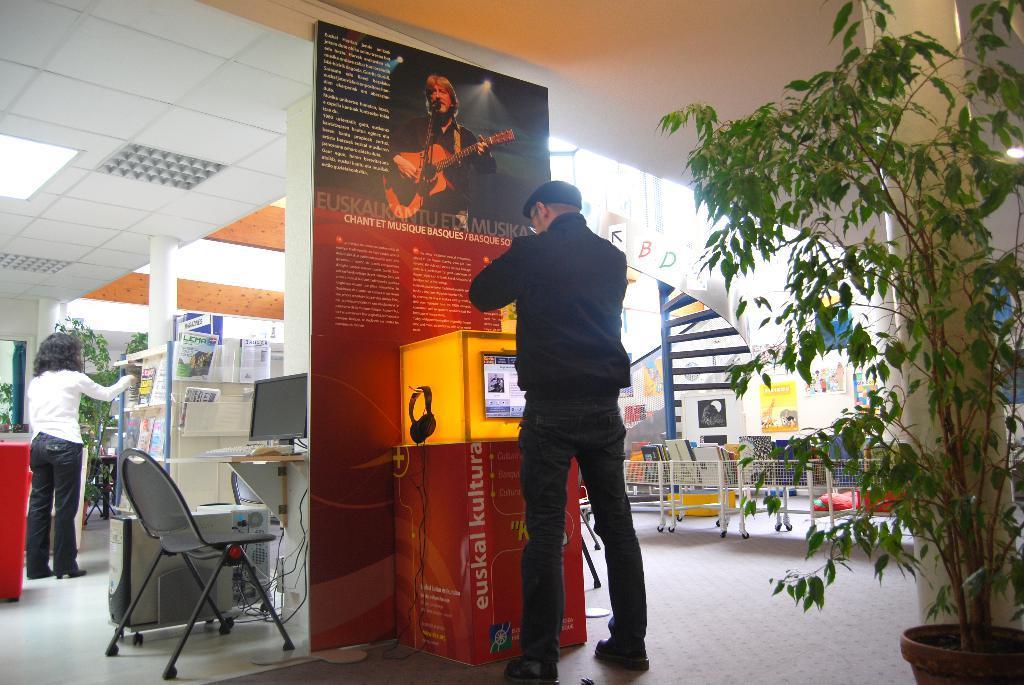Describe this image in one or two sentences. This image is taken in a mall where a person is standing in a middle and is looking at the machine at right side there is a house plant, a pillar and a container with a things in it. At the left there is a chair, a monitor and a desk and the c. p. u, and the woman is standing and is taking out a magazine from the magazine section. In the background there is a plant, a wall, a pillar. 